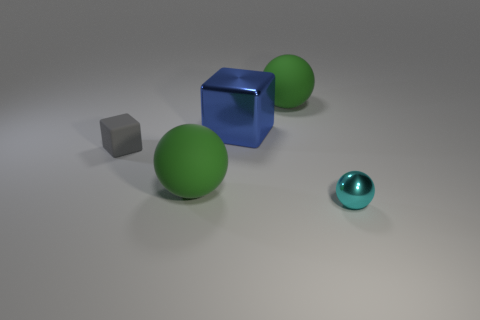Add 1 matte spheres. How many objects exist? 6 Subtract all spheres. How many objects are left? 2 Subtract 0 blue spheres. How many objects are left? 5 Subtract all small matte things. Subtract all small gray matte things. How many objects are left? 3 Add 1 big blue cubes. How many big blue cubes are left? 2 Add 4 big green spheres. How many big green spheres exist? 6 